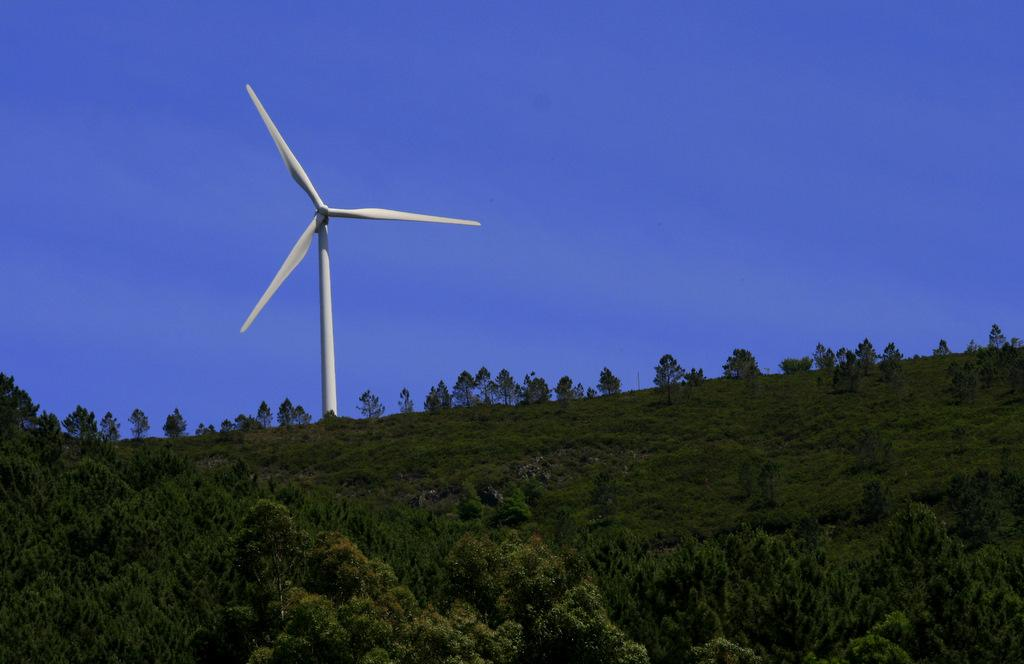What is covering the hill slope in the image? The hill slope is covered with plants and trees. What structure can be seen on top of the hill? There is a windmill on top of the hill. What is visible behind the windmill in the image? The sky is visible behind the windmill. What type of government is depicted in the image? There is no depiction of a government in the image; it features a hill with plants, trees, and a windmill. What is the current weather like in the image? The provided facts do not give information about the weather in the image. 